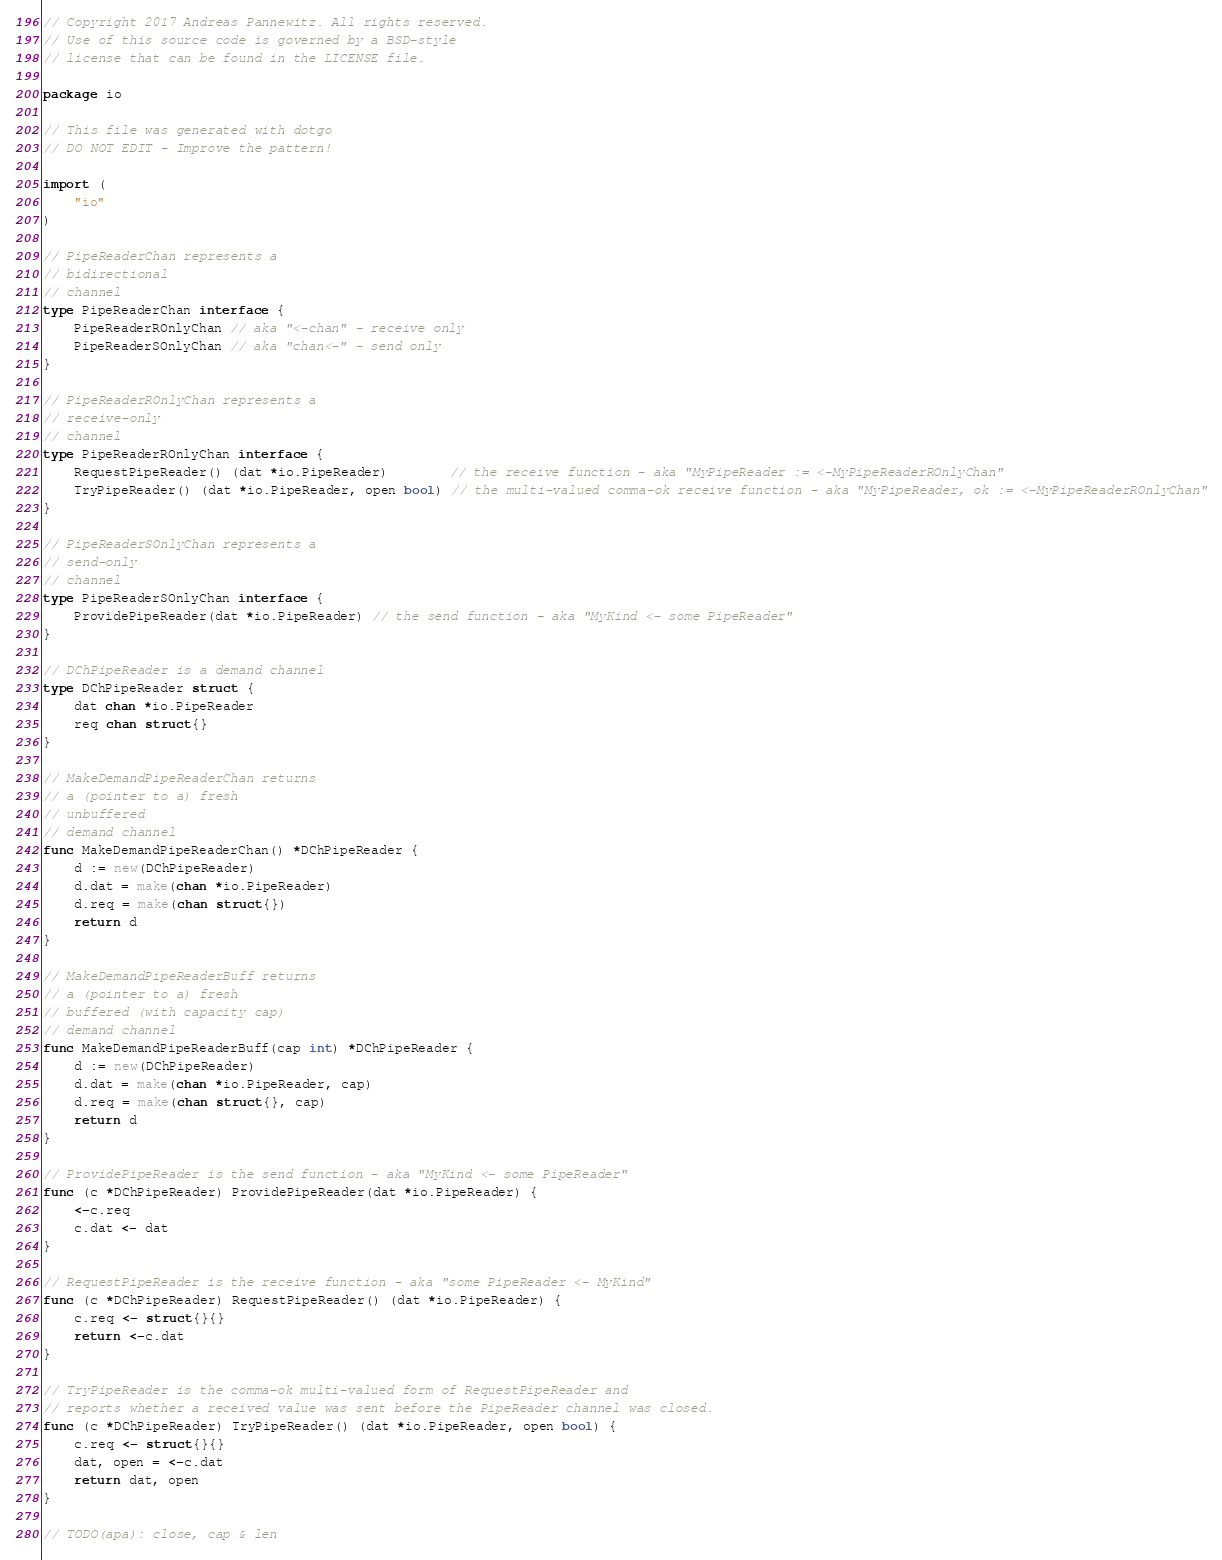Convert code to text. <code><loc_0><loc_0><loc_500><loc_500><_Go_>// Copyright 2017 Andreas Pannewitz. All rights reserved.
// Use of this source code is governed by a BSD-style
// license that can be found in the LICENSE file.

package io

// This file was generated with dotgo
// DO NOT EDIT - Improve the pattern!

import (
	"io"
)

// PipeReaderChan represents a
// bidirectional
// channel
type PipeReaderChan interface {
	PipeReaderROnlyChan // aka "<-chan" - receive only
	PipeReaderSOnlyChan // aka "chan<-" - send only
}

// PipeReaderROnlyChan represents a
// receive-only
// channel
type PipeReaderROnlyChan interface {
	RequestPipeReader() (dat *io.PipeReader)        // the receive function - aka "MyPipeReader := <-MyPipeReaderROnlyChan"
	TryPipeReader() (dat *io.PipeReader, open bool) // the multi-valued comma-ok receive function - aka "MyPipeReader, ok := <-MyPipeReaderROnlyChan"
}

// PipeReaderSOnlyChan represents a
// send-only
// channel
type PipeReaderSOnlyChan interface {
	ProvidePipeReader(dat *io.PipeReader) // the send function - aka "MyKind <- some PipeReader"
}

// DChPipeReader is a demand channel
type DChPipeReader struct {
	dat chan *io.PipeReader
	req chan struct{}
}

// MakeDemandPipeReaderChan returns
// a (pointer to a) fresh
// unbuffered
// demand channel
func MakeDemandPipeReaderChan() *DChPipeReader {
	d := new(DChPipeReader)
	d.dat = make(chan *io.PipeReader)
	d.req = make(chan struct{})
	return d
}

// MakeDemandPipeReaderBuff returns
// a (pointer to a) fresh
// buffered (with capacity cap)
// demand channel
func MakeDemandPipeReaderBuff(cap int) *DChPipeReader {
	d := new(DChPipeReader)
	d.dat = make(chan *io.PipeReader, cap)
	d.req = make(chan struct{}, cap)
	return d
}

// ProvidePipeReader is the send function - aka "MyKind <- some PipeReader"
func (c *DChPipeReader) ProvidePipeReader(dat *io.PipeReader) {
	<-c.req
	c.dat <- dat
}

// RequestPipeReader is the receive function - aka "some PipeReader <- MyKind"
func (c *DChPipeReader) RequestPipeReader() (dat *io.PipeReader) {
	c.req <- struct{}{}
	return <-c.dat
}

// TryPipeReader is the comma-ok multi-valued form of RequestPipeReader and
// reports whether a received value was sent before the PipeReader channel was closed.
func (c *DChPipeReader) TryPipeReader() (dat *io.PipeReader, open bool) {
	c.req <- struct{}{}
	dat, open = <-c.dat
	return dat, open
}

// TODO(apa): close, cap & len
</code> 